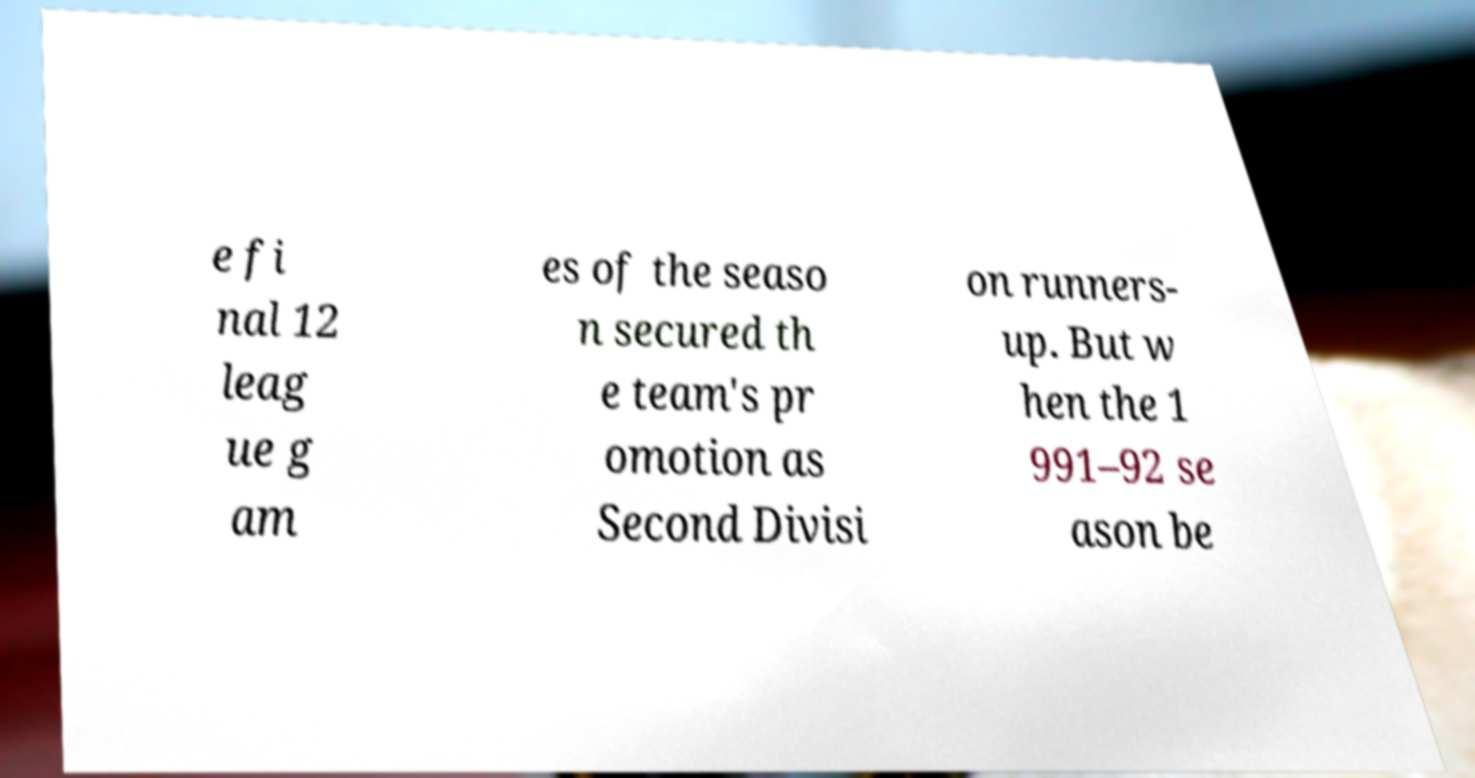Could you assist in decoding the text presented in this image and type it out clearly? e fi nal 12 leag ue g am es of the seaso n secured th e team's pr omotion as Second Divisi on runners- up. But w hen the 1 991–92 se ason be 